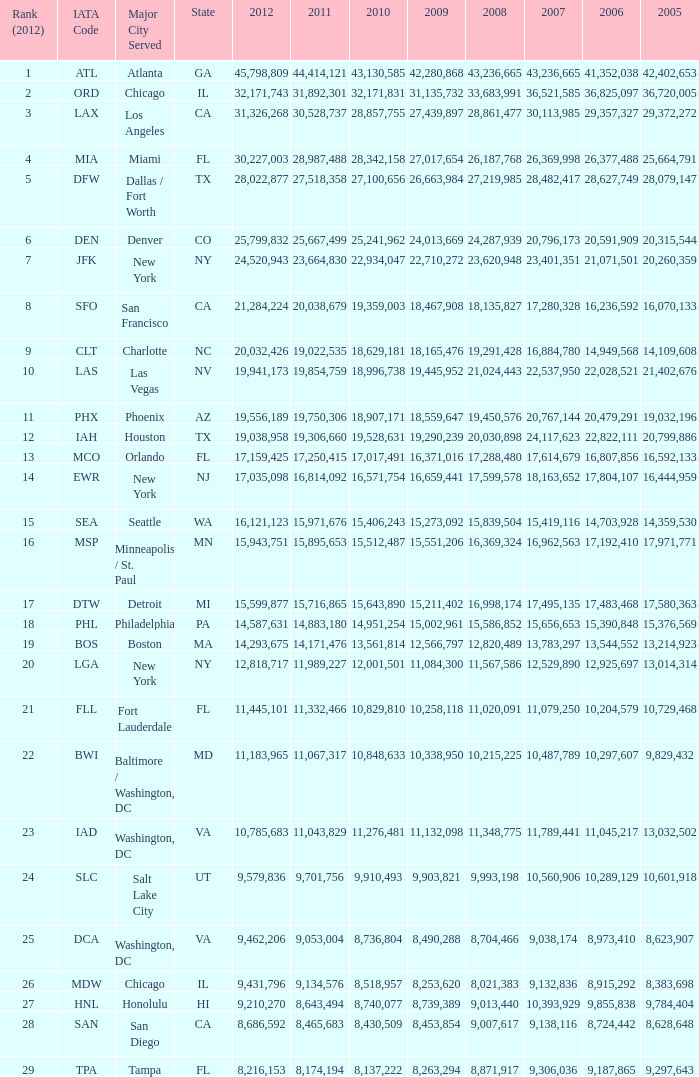When Philadelphia has a 2007 less than 20,796,173 and a 2008 more than 10,215,225, what is the smallest 2009? 15002961.0. 